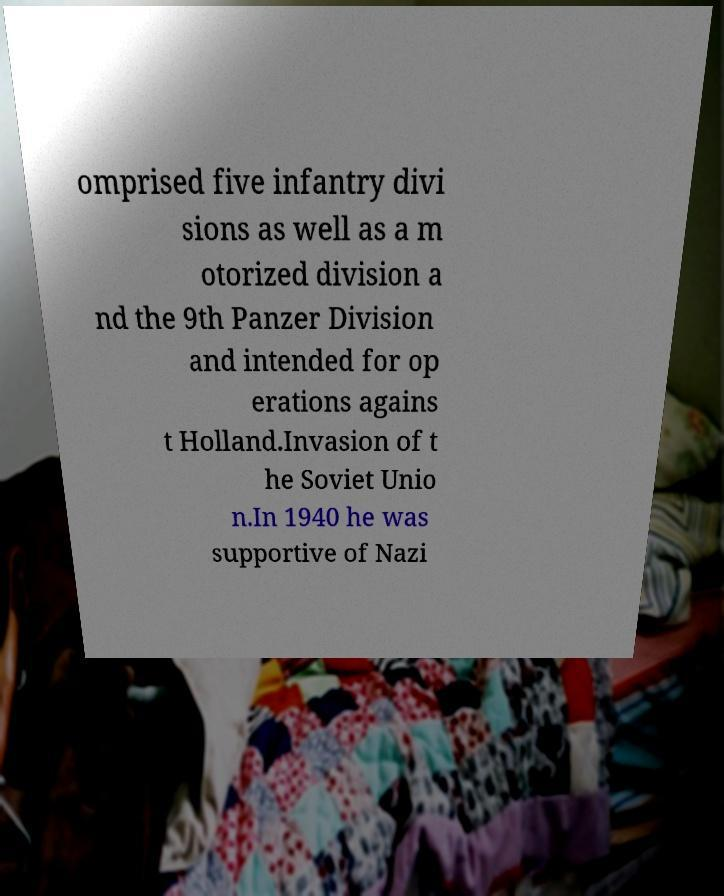I need the written content from this picture converted into text. Can you do that? omprised five infantry divi sions as well as a m otorized division a nd the 9th Panzer Division and intended for op erations agains t Holland.Invasion of t he Soviet Unio n.In 1940 he was supportive of Nazi 